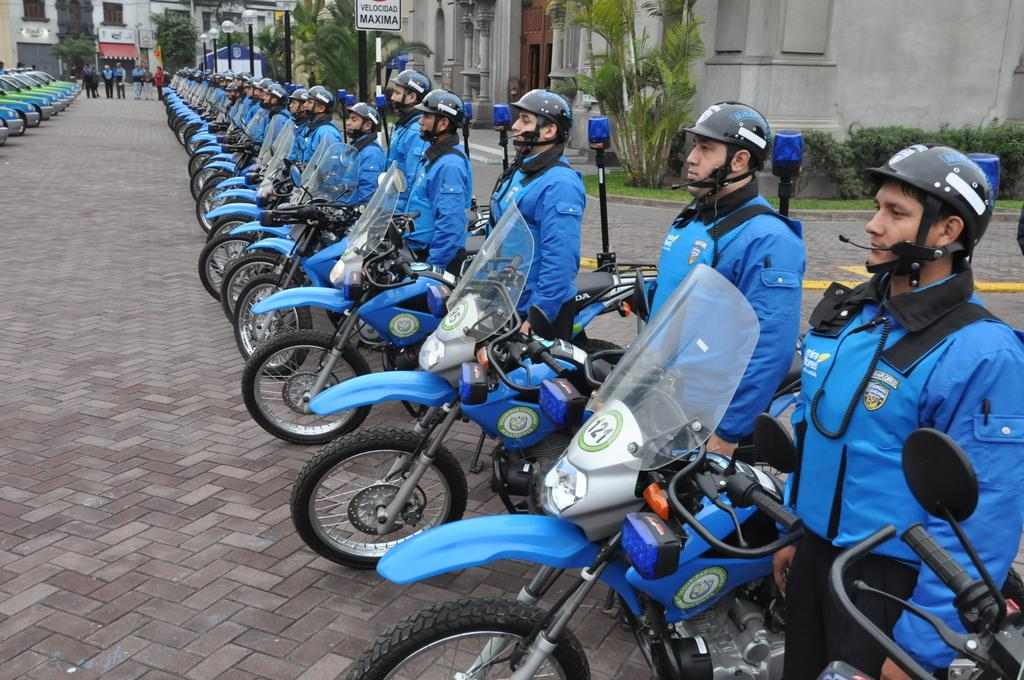What can be seen lined up in the image? There are bikes placed in a row in the image. Who or what is present in the image besides the bikes? There are people standing in the image. What can be seen in the distance in the image? There are buildings, trees, a board, and poles in the background of the image. What type of silk is being used to cover the hole in the image? There is no silk or hole present in the image. 